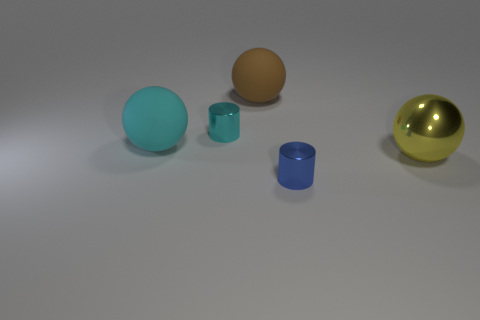There is a tiny thing that is made of the same material as the tiny blue cylinder; what shape is it?
Provide a succinct answer. Cylinder. Are there any other things that have the same shape as the large yellow shiny thing?
Provide a short and direct response. Yes. There is a large sphere that is right of the cyan shiny thing and to the left of the big shiny thing; what color is it?
Offer a terse response. Brown. What number of balls are either cyan metallic things or yellow metallic things?
Provide a short and direct response. 1. How many cyan metal things are the same size as the blue metal cylinder?
Your answer should be compact. 1. There is a small cylinder to the right of the tiny cyan cylinder; what number of yellow shiny objects are in front of it?
Give a very brief answer. 0. How big is the metallic thing that is both behind the tiny blue metallic cylinder and to the left of the large yellow thing?
Provide a succinct answer. Small. Are there more small cylinders than metal things?
Your answer should be very brief. No. There is a brown object on the left side of the yellow object; is its size the same as the large cyan rubber ball?
Your response must be concise. Yes. Are there fewer small cylinders than balls?
Your answer should be compact. Yes. 